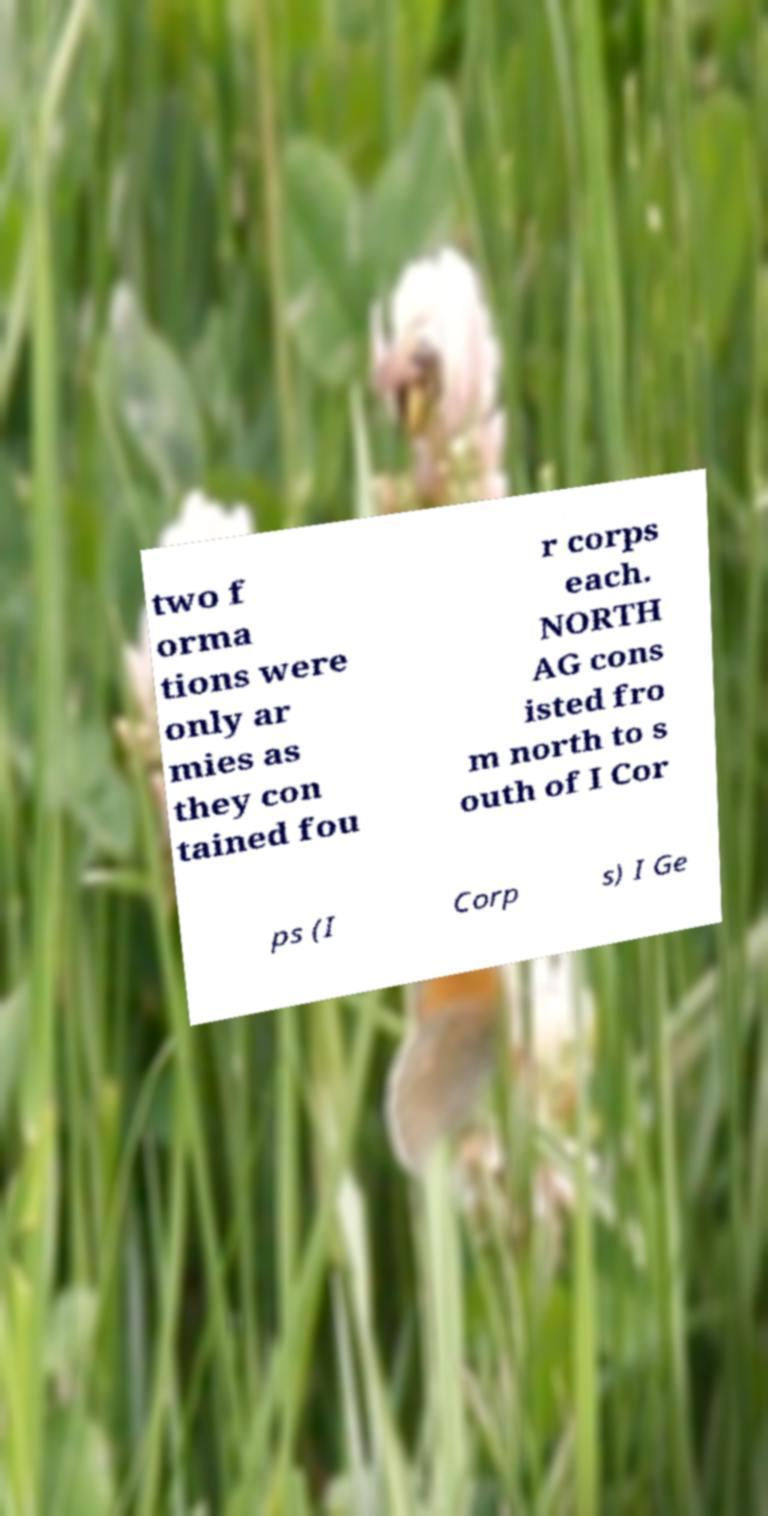There's text embedded in this image that I need extracted. Can you transcribe it verbatim? two f orma tions were only ar mies as they con tained fou r corps each. NORTH AG cons isted fro m north to s outh of I Cor ps (I Corp s) I Ge 